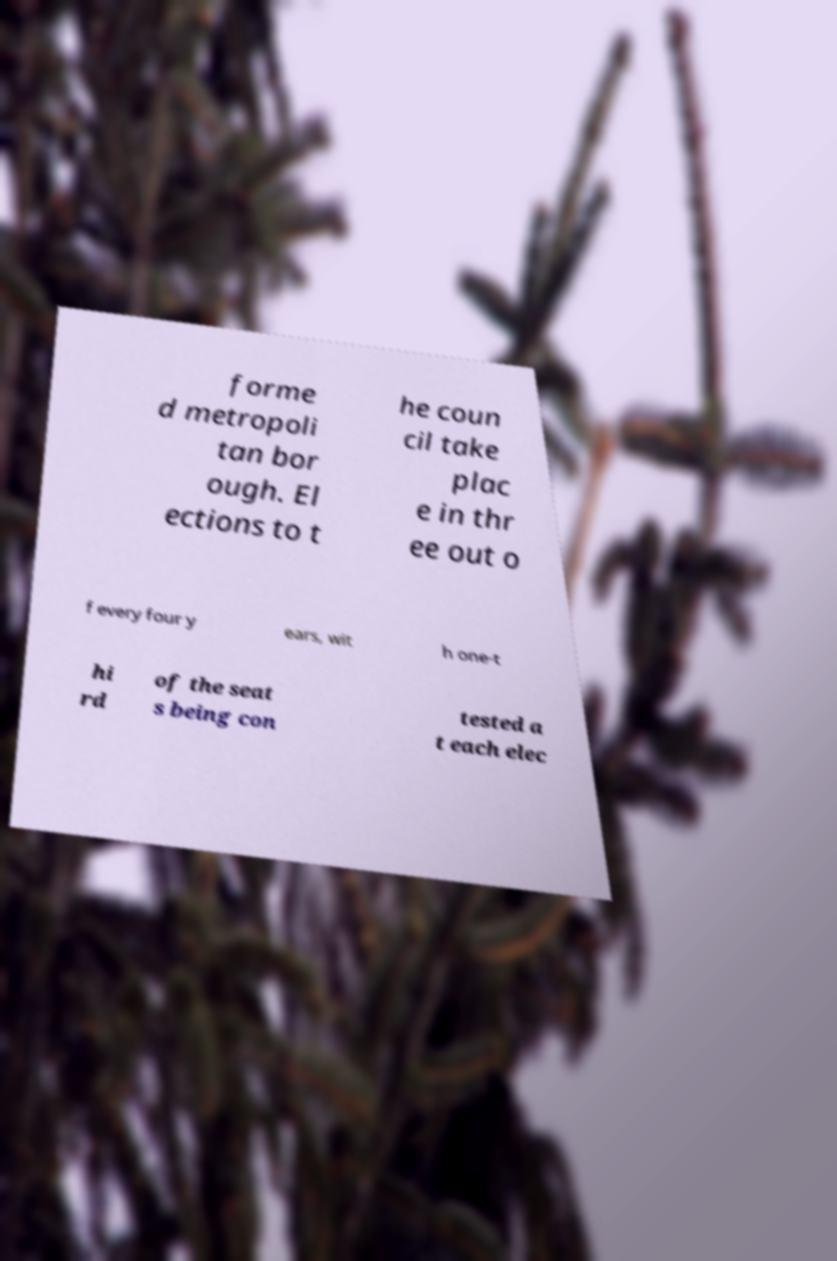Please identify and transcribe the text found in this image. forme d metropoli tan bor ough. El ections to t he coun cil take plac e in thr ee out o f every four y ears, wit h one-t hi rd of the seat s being con tested a t each elec 